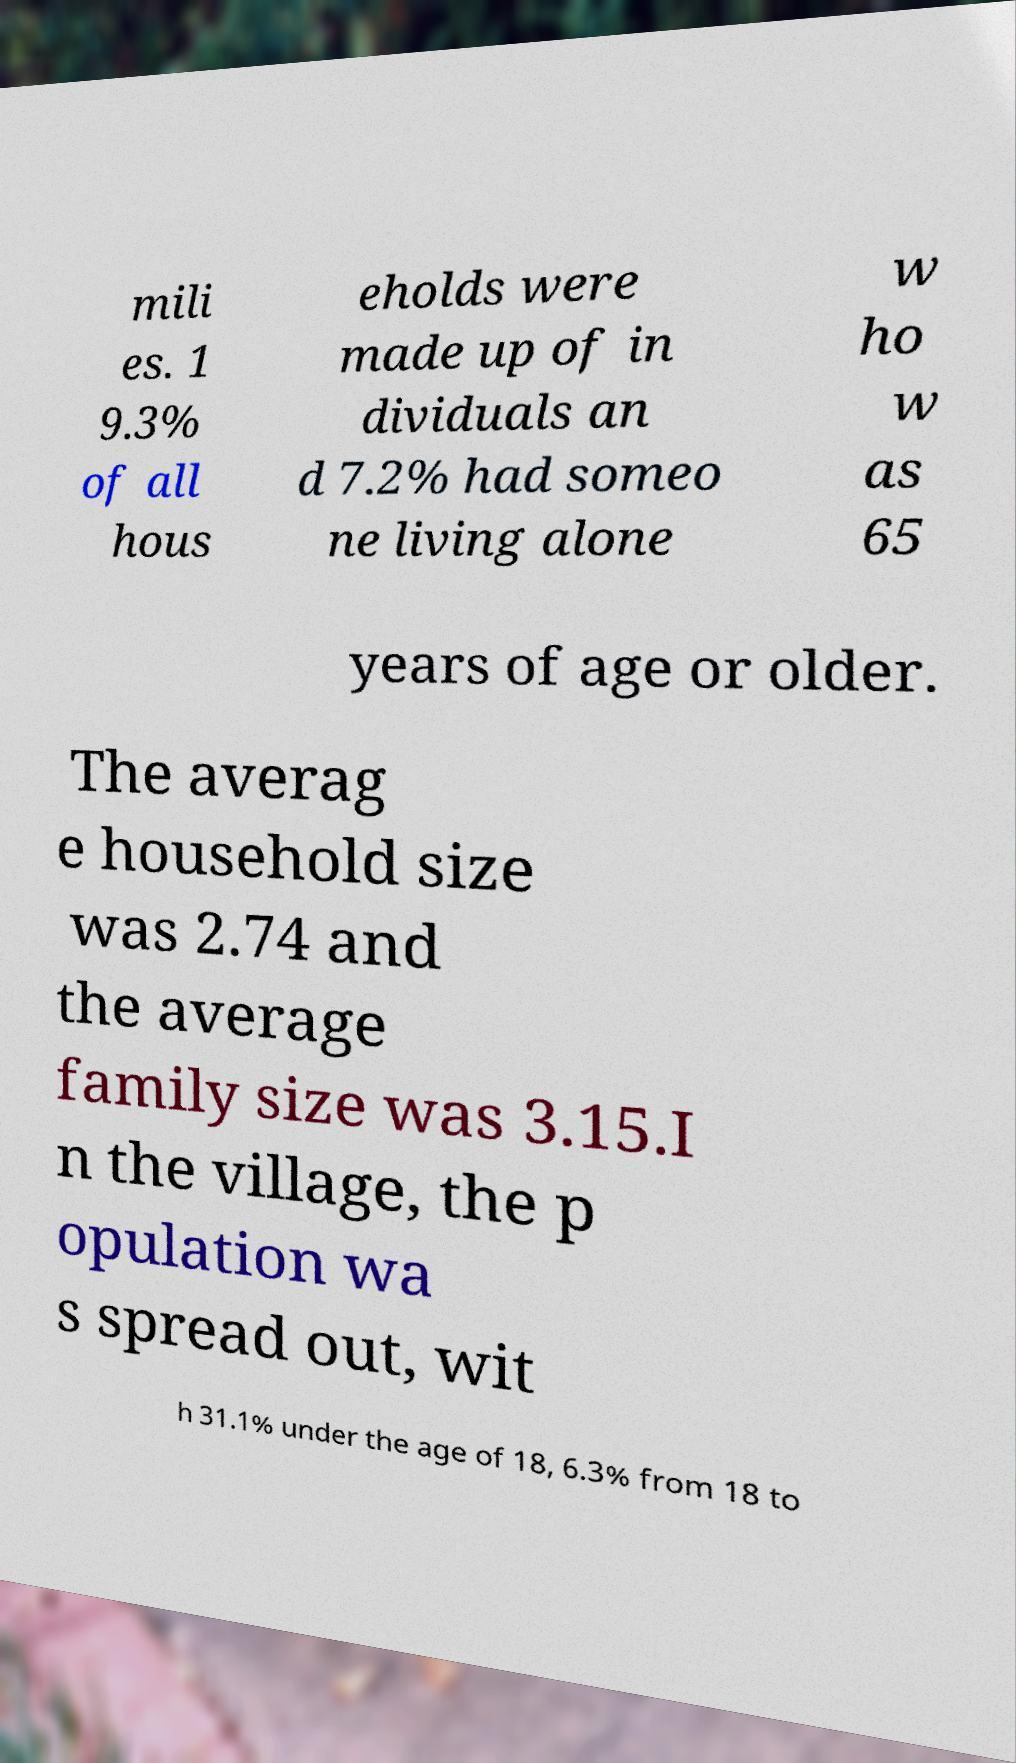What messages or text are displayed in this image? I need them in a readable, typed format. mili es. 1 9.3% of all hous eholds were made up of in dividuals an d 7.2% had someo ne living alone w ho w as 65 years of age or older. The averag e household size was 2.74 and the average family size was 3.15.I n the village, the p opulation wa s spread out, wit h 31.1% under the age of 18, 6.3% from 18 to 